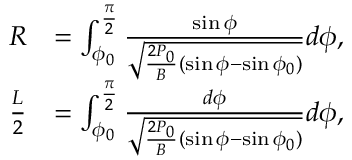<formula> <loc_0><loc_0><loc_500><loc_500>\begin{array} { r l } { R } & { = \int _ { \phi _ { 0 } } ^ { \frac { \pi } { 2 } } \frac { \sin \phi } { \sqrt { \frac { 2 P _ { 0 } } { B } ( \sin \phi - \sin \phi _ { 0 } ) } } d \phi , } \\ { \frac { L } { 2 } } & { = \int _ { \phi _ { 0 } } ^ { \frac { \pi } { 2 } } \frac { d \phi } { \sqrt { \frac { 2 P _ { 0 } } { B } ( \sin \phi - \sin \phi _ { 0 } ) } } d \phi , } \end{array}</formula> 